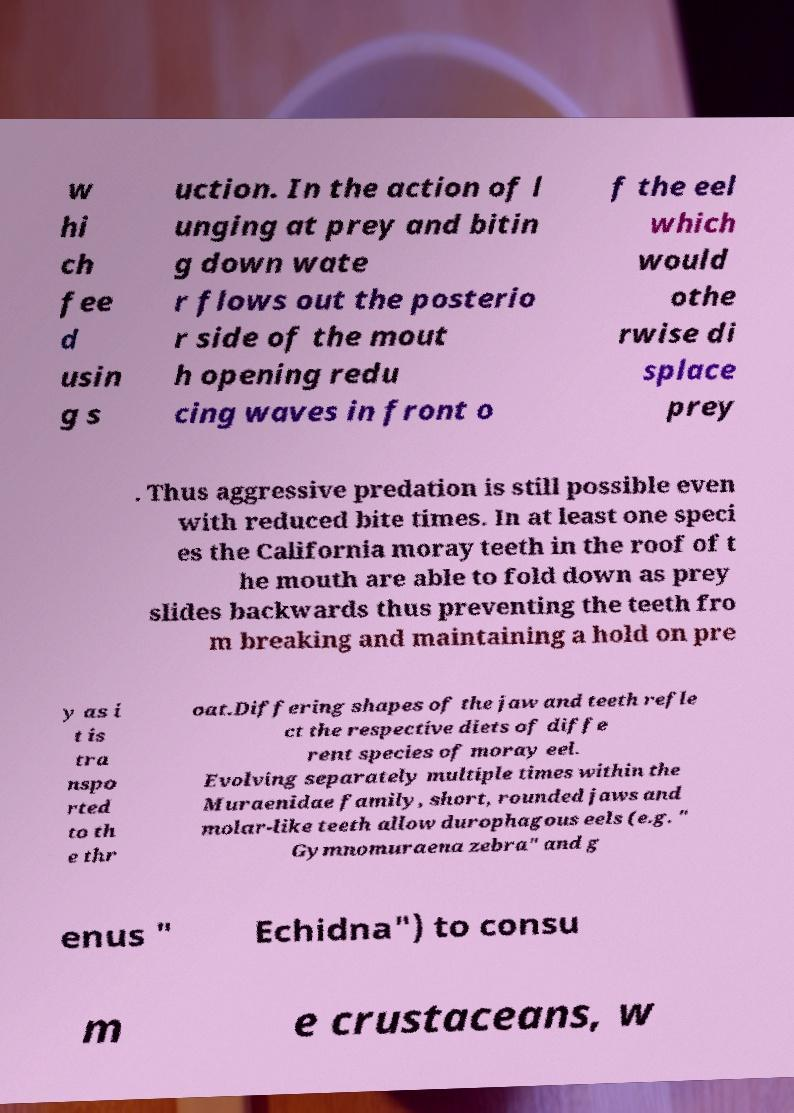Please read and relay the text visible in this image. What does it say? w hi ch fee d usin g s uction. In the action of l unging at prey and bitin g down wate r flows out the posterio r side of the mout h opening redu cing waves in front o f the eel which would othe rwise di splace prey . Thus aggressive predation is still possible even with reduced bite times. In at least one speci es the California moray teeth in the roof of t he mouth are able to fold down as prey slides backwards thus preventing the teeth fro m breaking and maintaining a hold on pre y as i t is tra nspo rted to th e thr oat.Differing shapes of the jaw and teeth refle ct the respective diets of diffe rent species of moray eel. Evolving separately multiple times within the Muraenidae family, short, rounded jaws and molar-like teeth allow durophagous eels (e.g. " Gymnomuraena zebra" and g enus " Echidna") to consu m e crustaceans, w 